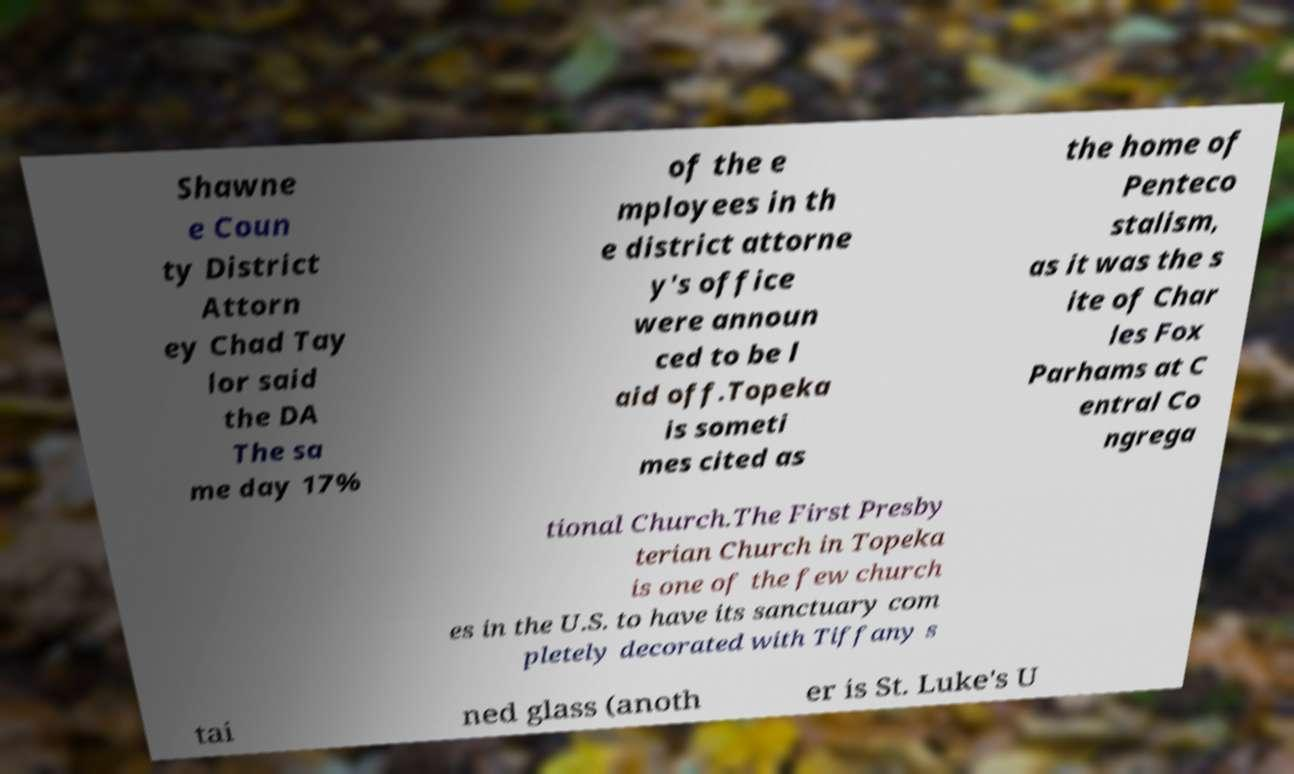Can you read and provide the text displayed in the image?This photo seems to have some interesting text. Can you extract and type it out for me? Shawne e Coun ty District Attorn ey Chad Tay lor said the DA The sa me day 17% of the e mployees in th e district attorne y's office were announ ced to be l aid off.Topeka is someti mes cited as the home of Penteco stalism, as it was the s ite of Char les Fox Parhams at C entral Co ngrega tional Church.The First Presby terian Church in Topeka is one of the few church es in the U.S. to have its sanctuary com pletely decorated with Tiffany s tai ned glass (anoth er is St. Luke's U 